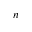Convert formula to latex. <formula><loc_0><loc_0><loc_500><loc_500>n</formula> 